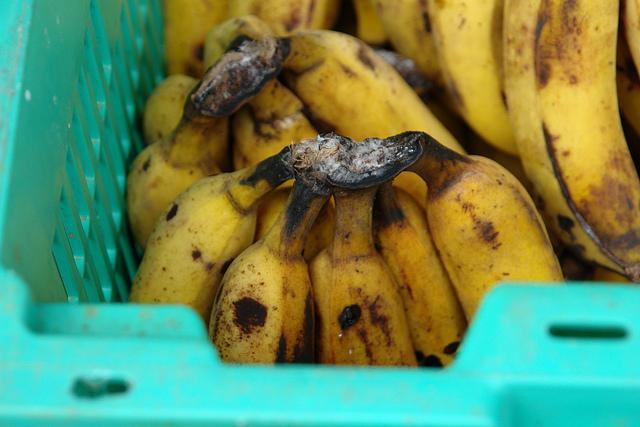How many bananas are visible?
Give a very brief answer. 6. How many red color pizza on the bowl?
Give a very brief answer. 0. 